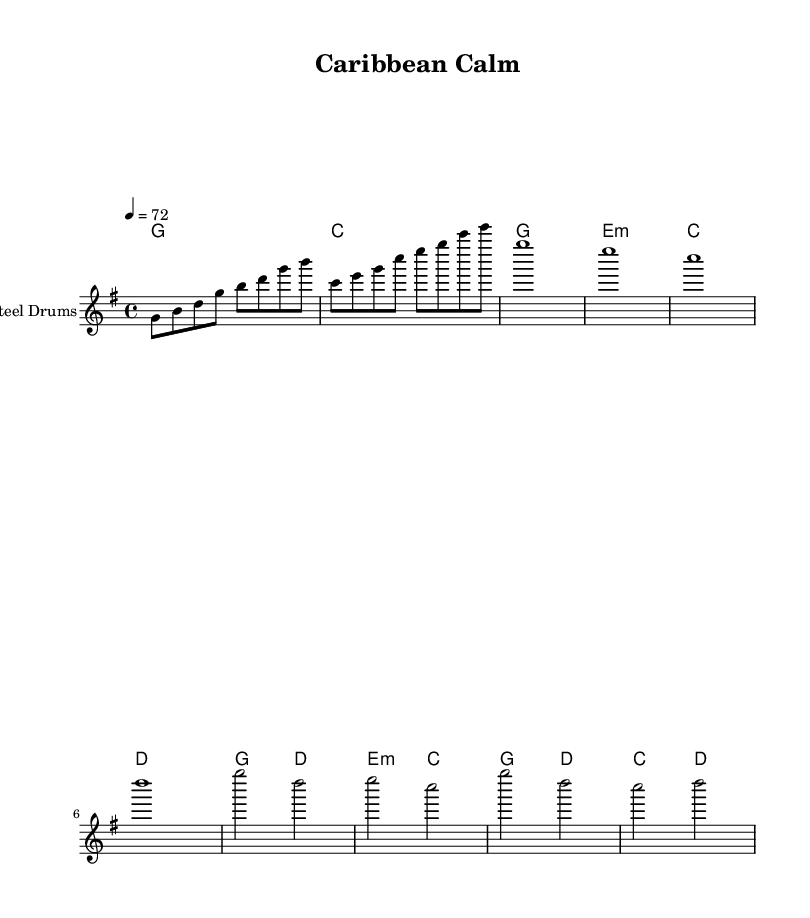What is the key signature of this music? The key signature is G major, indicated by one sharp, which is F sharp.
Answer: G major What is the time signature of this music? The time signature is four-four, which is represented by the notation "4/4."
Answer: 4/4 What is the tempo marking in this music? The tempo marking shows the beats per minute as 72, written at the beginning as "4 = 72."
Answer: 72 How many measures are in the chorus section? The chorus section consists of four measures, which can be counted from the corresponding notes and chords.
Answer: 4 Which instrument is featured in this piece? The featured instrument is the steel drums, mentioned in the instrument name at the beginning of the staff.
Answer: Steel Drums How many chords are played during the verse? There are four different chords played during the verse, as shown in the chord markings underneath the corresponding notes.
Answer: 4 What type of music does "Caribbean Calm" represent? The piece is a reggae fusion, integrating Caribbean rhythms and soothing melodies aimed at stress relief.
Answer: Reggae fusion 